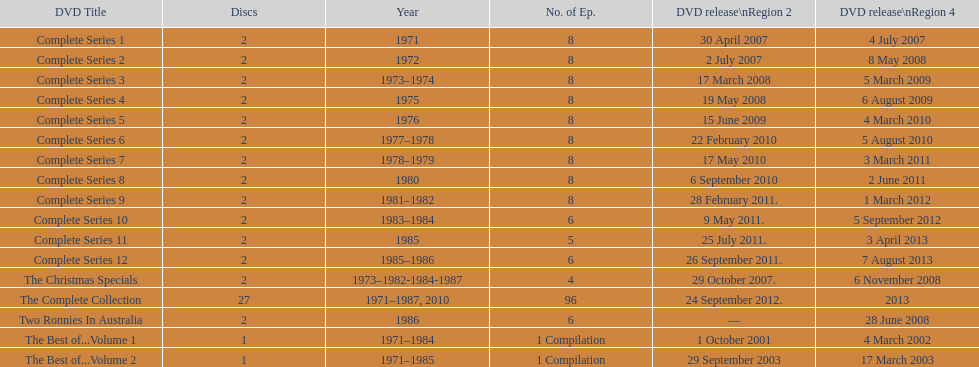What appears right after the entire series 11? Complete Series 12. 